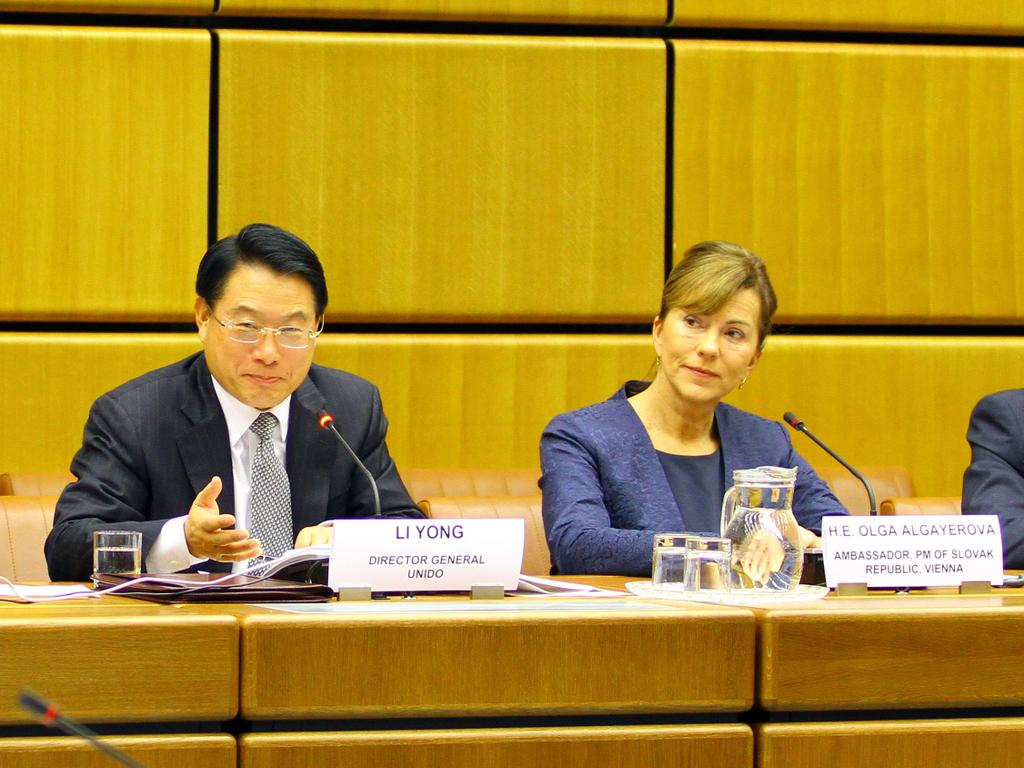What are the people in the image doing? The people in the image are sitting on chairs. What objects are used for amplifying sound in the image? Microphones are present in the image. What can be used for identifying the people in the image? Name boards are visible in the image. What is the container for holding liquid in the image? There is a jug in the image. What can be used for drinking in the image? Glasses are present in the image. What is on the table in the image? There are objects on the table. What can be seen in the background of the image? There is a wooden wall in the background of the image. How many babies are crawling on the wooden wall in the image? There are no babies present in the image; it only shows people sitting on chairs, microphones, name boards, a jug, glasses, objects on the table, and a wooden wall in the background. 